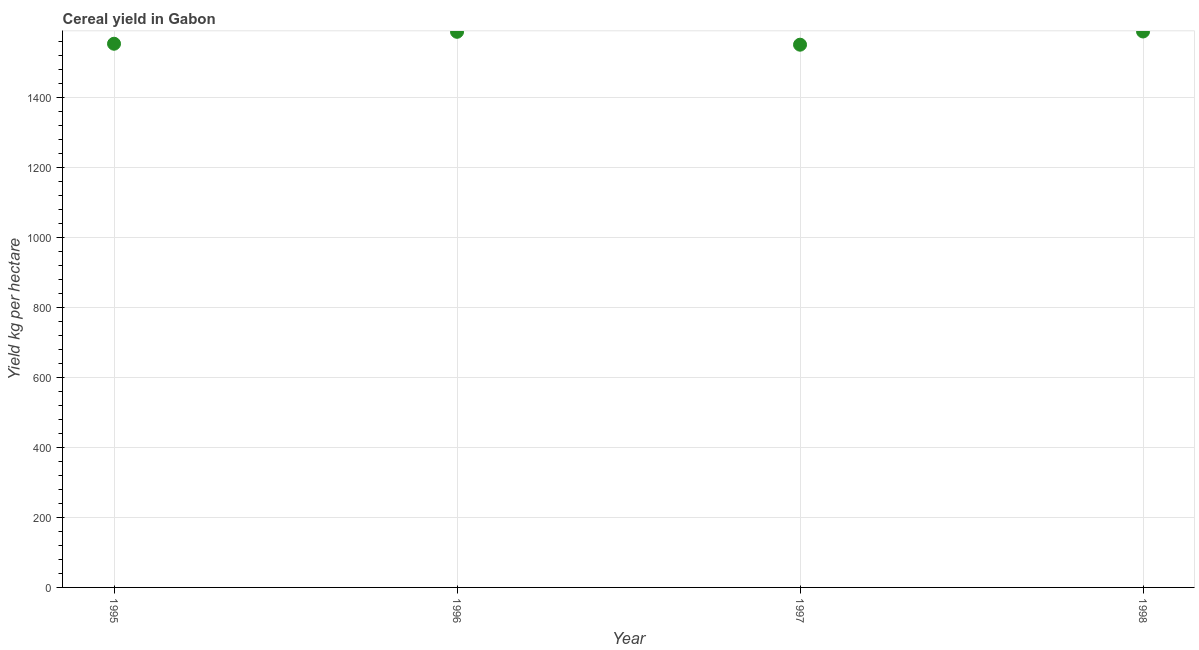What is the cereal yield in 1997?
Your answer should be compact. 1550.26. Across all years, what is the maximum cereal yield?
Your answer should be compact. 1587.97. Across all years, what is the minimum cereal yield?
Your answer should be very brief. 1550.26. In which year was the cereal yield minimum?
Provide a short and direct response. 1997. What is the sum of the cereal yield?
Provide a short and direct response. 6278.26. What is the difference between the cereal yield in 1996 and 1998?
Make the answer very short. -0.9. What is the average cereal yield per year?
Give a very brief answer. 1569.57. What is the median cereal yield?
Offer a very short reply. 1570.02. In how many years, is the cereal yield greater than 1160 kg per hectare?
Offer a very short reply. 4. Do a majority of the years between 1997 and 1998 (inclusive) have cereal yield greater than 80 kg per hectare?
Provide a succinct answer. Yes. What is the ratio of the cereal yield in 1997 to that in 1998?
Your response must be concise. 0.98. What is the difference between the highest and the second highest cereal yield?
Make the answer very short. 0.9. What is the difference between the highest and the lowest cereal yield?
Your answer should be very brief. 37.71. What is the difference between two consecutive major ticks on the Y-axis?
Offer a terse response. 200. Does the graph contain any zero values?
Offer a very short reply. No. Does the graph contain grids?
Offer a terse response. Yes. What is the title of the graph?
Your answer should be compact. Cereal yield in Gabon. What is the label or title of the Y-axis?
Give a very brief answer. Yield kg per hectare. What is the Yield kg per hectare in 1995?
Your answer should be very brief. 1552.97. What is the Yield kg per hectare in 1996?
Keep it short and to the point. 1587.07. What is the Yield kg per hectare in 1997?
Your response must be concise. 1550.26. What is the Yield kg per hectare in 1998?
Keep it short and to the point. 1587.97. What is the difference between the Yield kg per hectare in 1995 and 1996?
Offer a terse response. -34.1. What is the difference between the Yield kg per hectare in 1995 and 1997?
Keep it short and to the point. 2.71. What is the difference between the Yield kg per hectare in 1995 and 1998?
Your answer should be compact. -35. What is the difference between the Yield kg per hectare in 1996 and 1997?
Provide a short and direct response. 36.81. What is the difference between the Yield kg per hectare in 1996 and 1998?
Offer a very short reply. -0.9. What is the difference between the Yield kg per hectare in 1997 and 1998?
Your answer should be compact. -37.71. What is the ratio of the Yield kg per hectare in 1995 to that in 1996?
Keep it short and to the point. 0.98. What is the ratio of the Yield kg per hectare in 1995 to that in 1997?
Make the answer very short. 1. What is the ratio of the Yield kg per hectare in 1996 to that in 1997?
Give a very brief answer. 1.02. What is the ratio of the Yield kg per hectare in 1997 to that in 1998?
Make the answer very short. 0.98. 